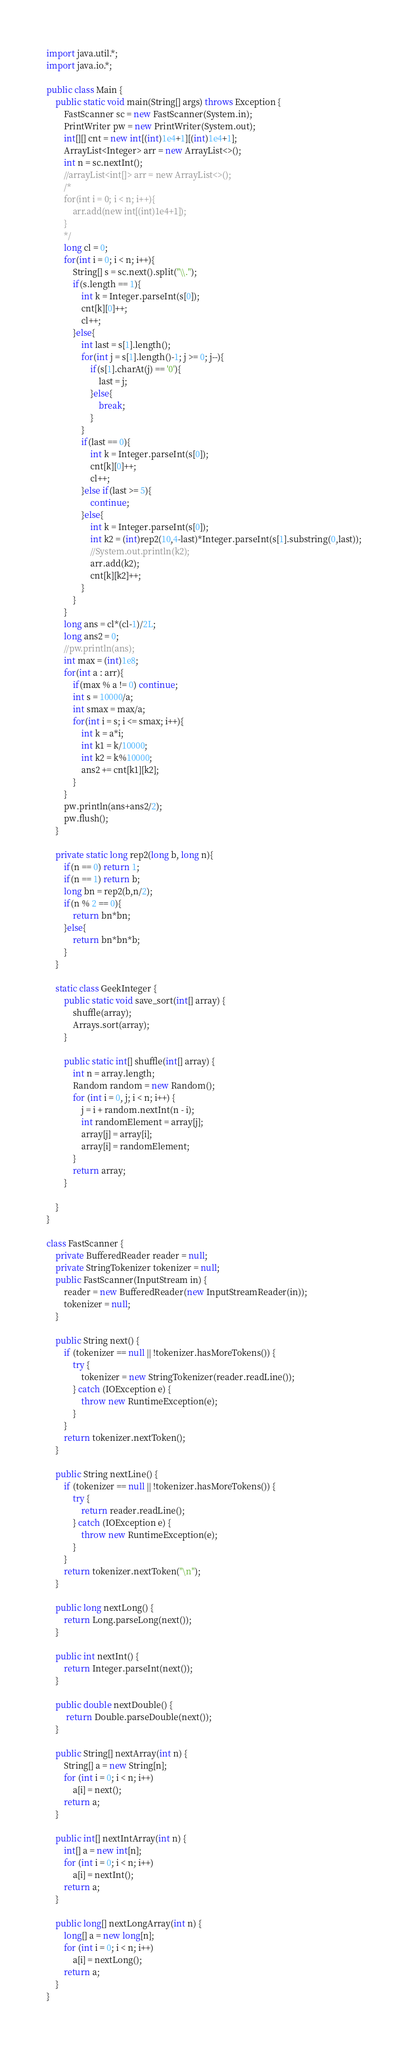<code> <loc_0><loc_0><loc_500><loc_500><_Java_>import java.util.*;
import java.io.*;
 
public class Main {
    public static void main(String[] args) throws Exception {
        FastScanner sc = new FastScanner(System.in);
        PrintWriter pw = new PrintWriter(System.out);
        int[][] cnt = new int[(int)1e4+1][(int)1e4+1];
        ArrayList<Integer> arr = new ArrayList<>();
        int n = sc.nextInt();
        //arrayList<int[]> arr = new ArrayList<>();
        /*
        for(int i = 0; i < n; i++){
            arr.add(new int[(int)1e4+1]);        
        }
        */
        long cl = 0;
        for(int i = 0; i < n; i++){
            String[] s = sc.next().split("\\.");
            if(s.length == 1){
                int k = Integer.parseInt(s[0]);
                cnt[k][0]++;
                cl++;
            }else{
                int last = s[1].length();
                for(int j = s[1].length()-1; j >= 0; j--){
                    if(s[1].charAt(j) == '0'){
                        last = j;
                    }else{
                        break;
                    }
                }
                if(last == 0){
                    int k = Integer.parseInt(s[0]);
                    cnt[k][0]++;
                    cl++;
                }else if(last >= 5){
                    continue;
                }else{
                    int k = Integer.parseInt(s[0]);
                    int k2 = (int)rep2(10,4-last)*Integer.parseInt(s[1].substring(0,last));
                    //System.out.println(k2);
                    arr.add(k2);
                    cnt[k][k2]++;
                }
            }
        }
        long ans = cl*(cl-1)/2L;
        long ans2 = 0;
        //pw.println(ans);
        int max = (int)1e8;
        for(int a : arr){
            if(max % a != 0) continue;
            int s = 10000/a;
            int smax = max/a;
            for(int i = s; i <= smax; i++){
                int k = a*i;
                int k1 = k/10000;
                int k2 = k%10000;
                ans2 += cnt[k1][k2];
            }
        }
        pw.println(ans+ans2/2);
        pw.flush();
    }
    
    private static long rep2(long b, long n){
        if(n == 0) return 1;
        if(n == 1) return b;
        long bn = rep2(b,n/2);
        if(n % 2 == 0){
            return bn*bn;
        }else{
            return bn*bn*b;
        }
    }

    static class GeekInteger {
        public static void save_sort(int[] array) {
            shuffle(array);
            Arrays.sort(array);
        }
 
        public static int[] shuffle(int[] array) {
            int n = array.length;
            Random random = new Random();
            for (int i = 0, j; i < n; i++) {
                j = i + random.nextInt(n - i);
                int randomElement = array[j];
                array[j] = array[i];
                array[i] = randomElement;
            }
            return array;
        }
 
    }
}

class FastScanner {
    private BufferedReader reader = null;
    private StringTokenizer tokenizer = null;
    public FastScanner(InputStream in) {
        reader = new BufferedReader(new InputStreamReader(in));
        tokenizer = null;
    }

    public String next() {
        if (tokenizer == null || !tokenizer.hasMoreTokens()) {
            try {
                tokenizer = new StringTokenizer(reader.readLine());
            } catch (IOException e) {
                throw new RuntimeException(e);
            }
        }
        return tokenizer.nextToken();
    }

    public String nextLine() {
        if (tokenizer == null || !tokenizer.hasMoreTokens()) {
            try {
                return reader.readLine();
            } catch (IOException e) {
                throw new RuntimeException(e);
            }
        }
        return tokenizer.nextToken("\n");
    }

    public long nextLong() {
        return Long.parseLong(next());
    }

    public int nextInt() {
        return Integer.parseInt(next());
    }

    public double nextDouble() {
         return Double.parseDouble(next());
    }
    
    public String[] nextArray(int n) {
        String[] a = new String[n];
        for (int i = 0; i < n; i++)
            a[i] = next();
        return a;
    }

    public int[] nextIntArray(int n) {
        int[] a = new int[n];
        for (int i = 0; i < n; i++)
            a[i] = nextInt();
        return a;
    }

    public long[] nextLongArray(int n) {
        long[] a = new long[n];
        for (int i = 0; i < n; i++)
            a[i] = nextLong();
        return a;
    } 
}
</code> 